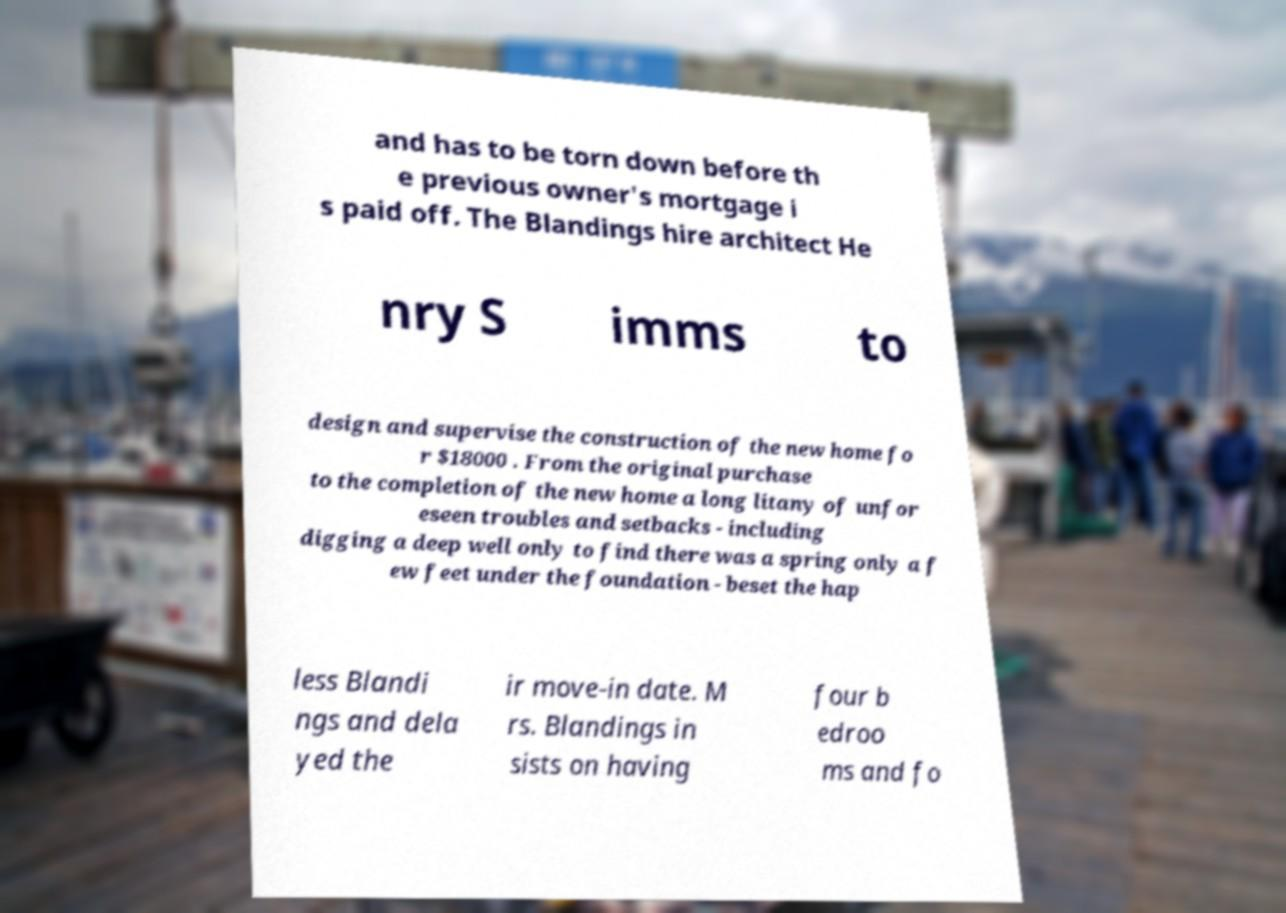I need the written content from this picture converted into text. Can you do that? and has to be torn down before th e previous owner's mortgage i s paid off. The Blandings hire architect He nry S imms to design and supervise the construction of the new home fo r $18000 . From the original purchase to the completion of the new home a long litany of unfor eseen troubles and setbacks - including digging a deep well only to find there was a spring only a f ew feet under the foundation - beset the hap less Blandi ngs and dela yed the ir move-in date. M rs. Blandings in sists on having four b edroo ms and fo 